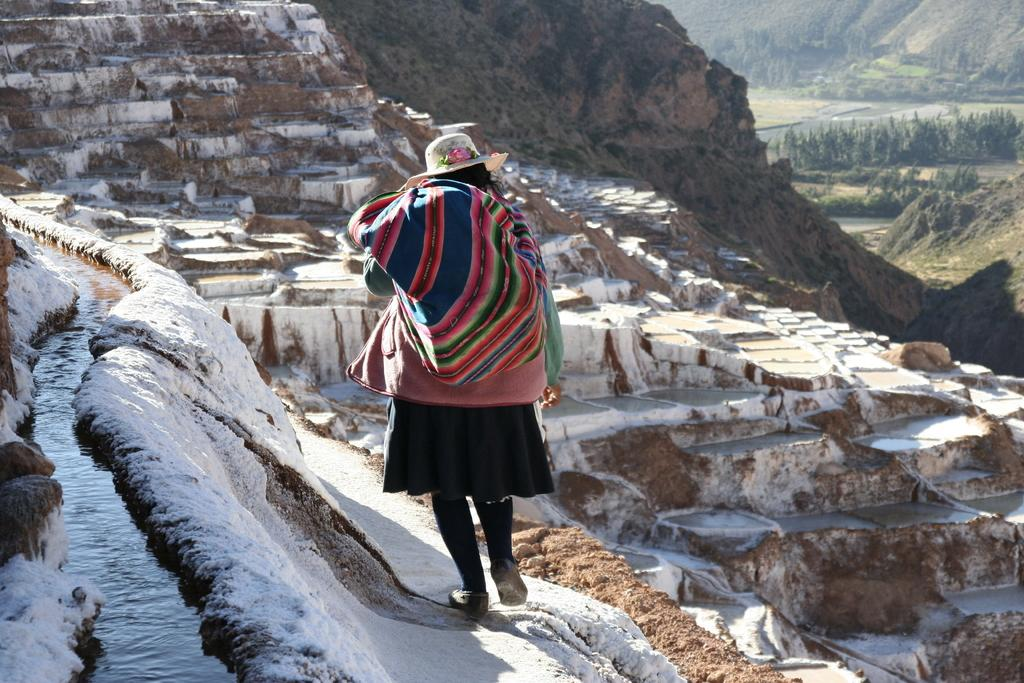What geographical feature is present in the image? There is a hill in the image. What is happening on the hill? There is a person on the hill. What is the person holding? The person is holding a colorful cloth. What type of headwear is the person wearing? The person is wearing a cap. What type of vegetation can be seen on the right side of the image? There are bushes visible on the right side of the image. Can you tell me how many plants the person is pushing in the image? There are no plants present in the image, nor is the person pushing any. Is there a swing visible in the image? No, there is no swing present in the image. 